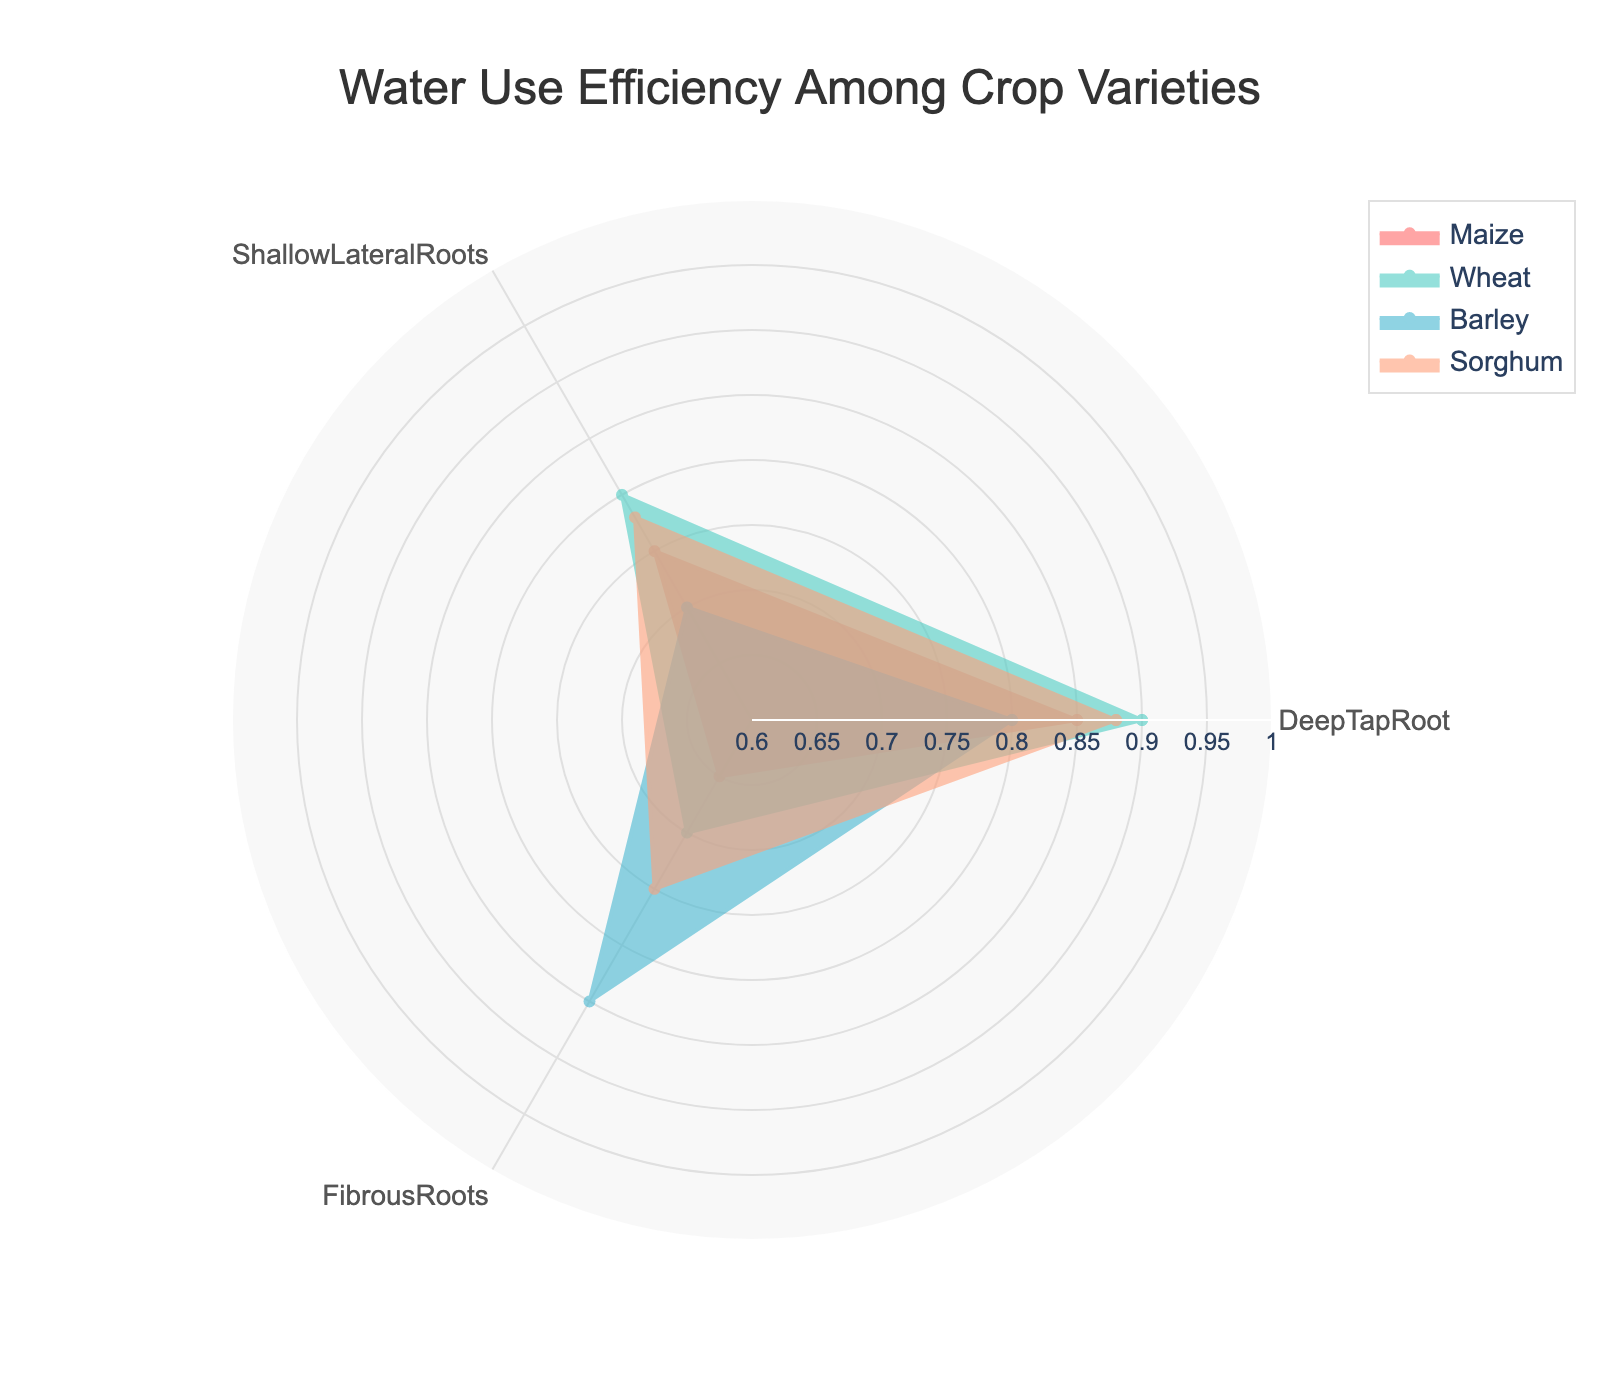What's the title of the chart? The title is centered at the top of the chart and reads "Water Use Efficiency Among Crop Varieties".
Answer: Water Use Efficiency Among Crop Varieties How many crop varieties are displayed in the chart? The chart shows four distinct crop varieties as indicated by the legend and the lines on the radar chart: Maize, Wheat, Barley, and Sorghum.
Answer: Four Which crop variety has the highest water use efficiency for Deep Tap Root? By examining the radial axis corresponding to "Deep Tap Root", Wheat scores the highest with a value of 0.90.
Answer: Wheat Which crop variety shows the lowest water use efficiency for Fibrous Roots? From the visual data, Maize has the lowest value for Fibrous Roots, at 0.65.
Answer: Maize What is the average water use efficiency for Barley across all root structures? The values for Barley are 0.80 (Deep Tap Root), 0.70 (Shallow Lateral Roots), and 0.85 (Fibrous Roots). Summing these gives 2.35, and the average is 2.35 / 3 ≈ 0.78.
Answer: 0.78 Which crop variety has the most consistent water use efficiency across all root structures? Consistency can be observed by visually assessing the variance in values for each crop. Sorghum maintains values close to each other across all root structures (0.88, 0.78, 0.75), displaying less variance compared to others.
Answer: Sorghum How does the water use efficiency of Maize compare to that of Sorghum for Deep Tap Root? Maize has a Deep Tap Root value of 0.85, while Sorghum has 0.88, meaning Sorghum scores slightly higher.
Answer: Sorghum is higher What is the combined total water use efficiency for Wheat and Barley for Shallow Lateral Roots? For Wheat, Shallow Lateral Roots is 0.80 and for Barley, it is 0.70. Together, 0.80 + 0.70 = 1.50.
Answer: 1.50 Which root structure shows the widest range of water use efficiency values across the crop varieties? By comparing the root structures, it is evident that "Deep Tap Root" ranges from 0.80 to 0.90, a range of 0.10. "Shallow Lateral Roots" ranges from 0.70 to 0.80 (0.10), and "Fibrous Roots" ranges from 0.65 to 0.85 (0.20). Hence, "Fibrous Roots" has the widest range.
Answer: Fibrous Roots 